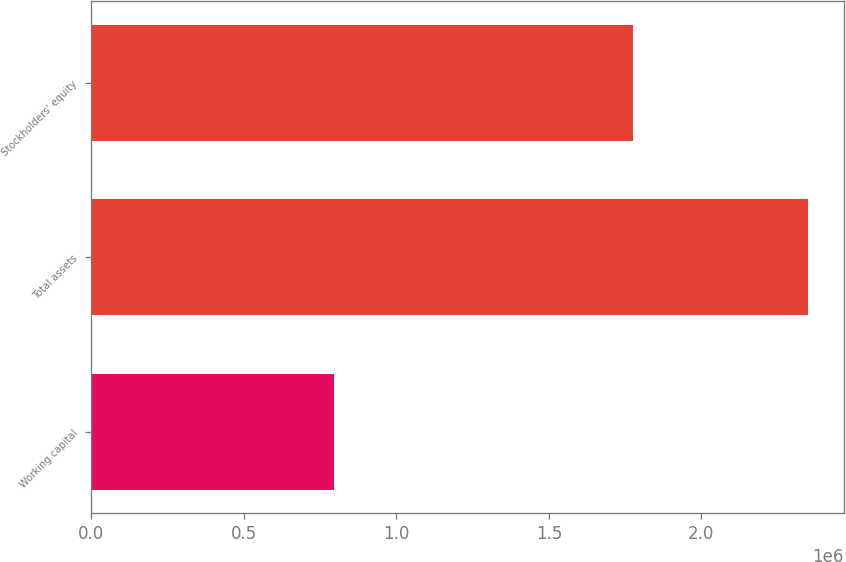Convert chart. <chart><loc_0><loc_0><loc_500><loc_500><bar_chart><fcel>Working capital<fcel>Total assets<fcel>Stockholders' equity<nl><fcel>796213<fcel>2.34864e+06<fcel>1.77666e+06<nl></chart> 